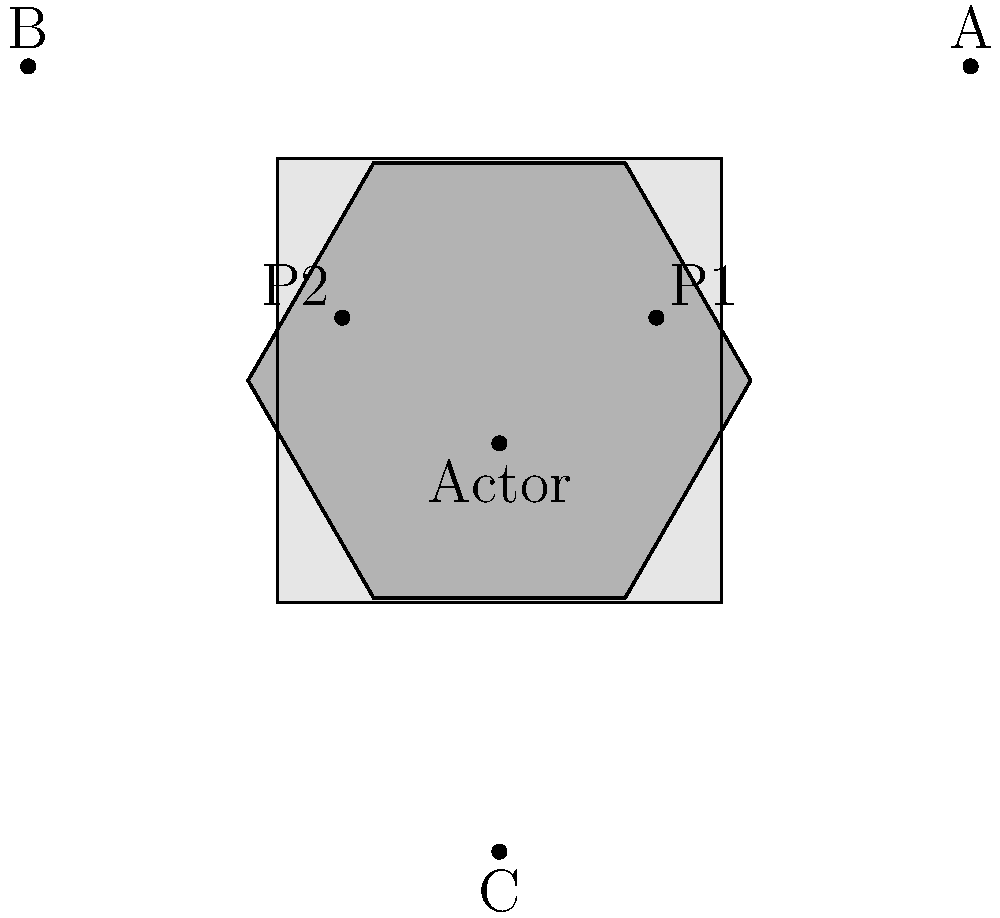As a playwright, you're planning a scene where an actor stands between two props on stage. From which audience perspective (A, B, or C) would the actor appear to be exactly in the middle of the two props? To determine from which perspective the actor appears exactly in the middle of the two props, we need to consider the relative positions of the audience members and the stage elements:

1. Analyze the stage layout:
   - The actor is positioned slightly behind the center of the stage.
   - Prop 1 (P1) is on the right side of the stage.
   - Prop 2 (P2) is on the left side of the stage.

2. Consider each audience perspective:
   A: From the right side of the audience
   B: From the left side of the audience
   C: From the center of the audience, but further back

3. Evaluate each perspective:
   A: From this angle, the actor would appear closer to P2 (left prop) than P1.
   B: From this angle, the actor would appear closer to P1 (right prop) than P2.
   C: From this central position, the actor would appear equidistant from both props.

4. Conclusion:
   The perspective that shows the actor exactly in the middle of the two props is C.

This spatial reasoning is crucial for a playwright to understand how different staging choices affect the audience's perception of the scene.
Answer: C 